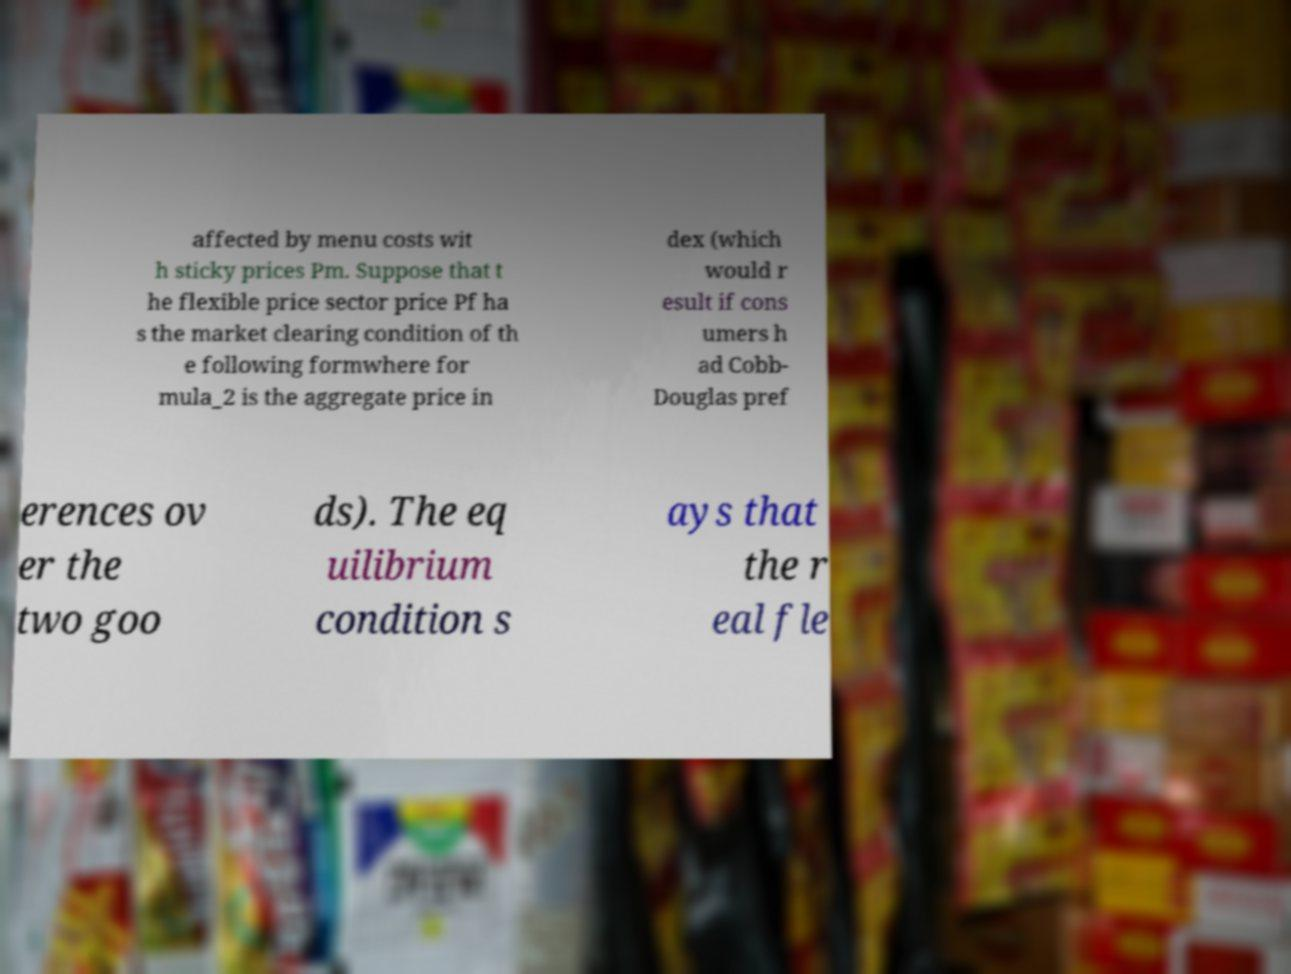Could you assist in decoding the text presented in this image and type it out clearly? affected by menu costs wit h sticky prices Pm. Suppose that t he flexible price sector price Pf ha s the market clearing condition of th e following formwhere for mula_2 is the aggregate price in dex (which would r esult if cons umers h ad Cobb- Douglas pref erences ov er the two goo ds). The eq uilibrium condition s ays that the r eal fle 